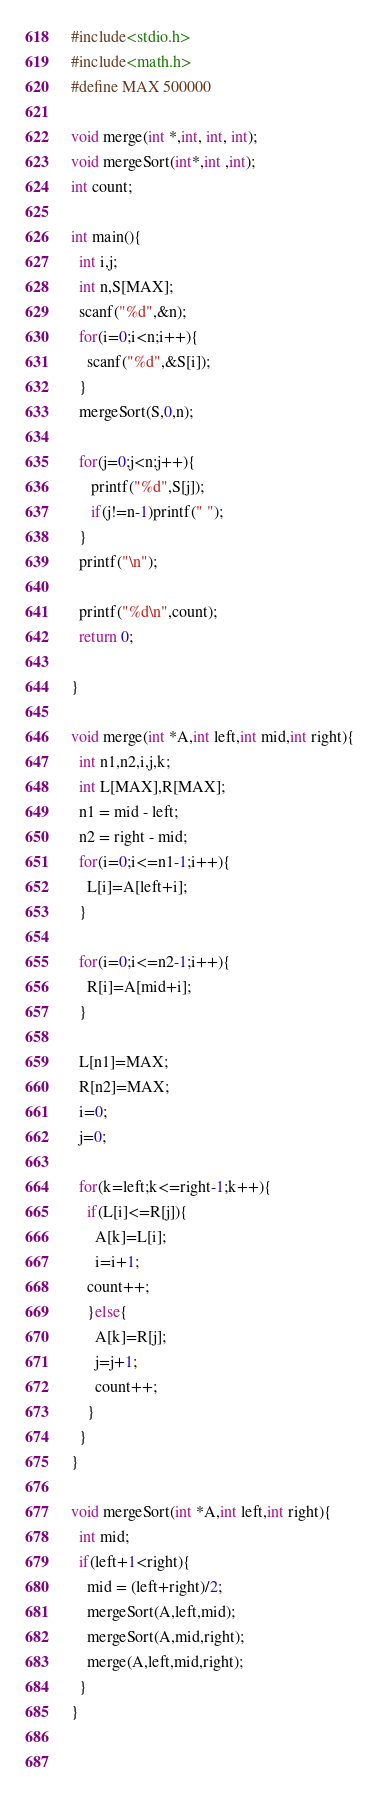<code> <loc_0><loc_0><loc_500><loc_500><_C_>#include<stdio.h>
#include<math.h>
#define MAX 500000

void merge(int *,int, int, int);
void mergeSort(int*,int ,int); 
int count;

int main(){
  int i,j;
  int n,S[MAX];
  scanf("%d",&n);
  for(i=0;i<n;i++){
    scanf("%d",&S[i]);
  }
  mergeSort(S,0,n);

  for(j=0;j<n;j++){
     printf("%d",S[j]);
     if(j!=n-1)printf(" ");
  }
  printf("\n");
   
  printf("%d\n",count);
  return 0;
  
}  

void merge(int *A,int left,int mid,int right){
  int n1,n2,i,j,k;
  int L[MAX],R[MAX];
  n1 = mid - left;
  n2 = right - mid;
  for(i=0;i<=n1-1;i++){
    L[i]=A[left+i];
  }

  for(i=0;i<=n2-1;i++){
    R[i]=A[mid+i];
  }
  
  L[n1]=MAX;
  R[n2]=MAX;
  i=0;
  j=0;

  for(k=left;k<=right-1;k++){
    if(L[i]<=R[j]){
      A[k]=L[i];
      i=i+1;
    count++;  
    }else{
      A[k]=R[j];
      j=j+1;
      count++;
    }
  }
}

void mergeSort(int *A,int left,int right){
  int mid;  
  if(left+1<right){
    mid = (left+right)/2;
    mergeSort(A,left,mid);
    mergeSort(A,mid,right);
    merge(A,left,mid,right);
  }
}

  

</code> 